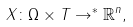<formula> <loc_0><loc_0><loc_500><loc_500>X \colon \Omega \times T \rightarrow ^ { * } { \mathbb { R } } ^ { n } ,</formula> 